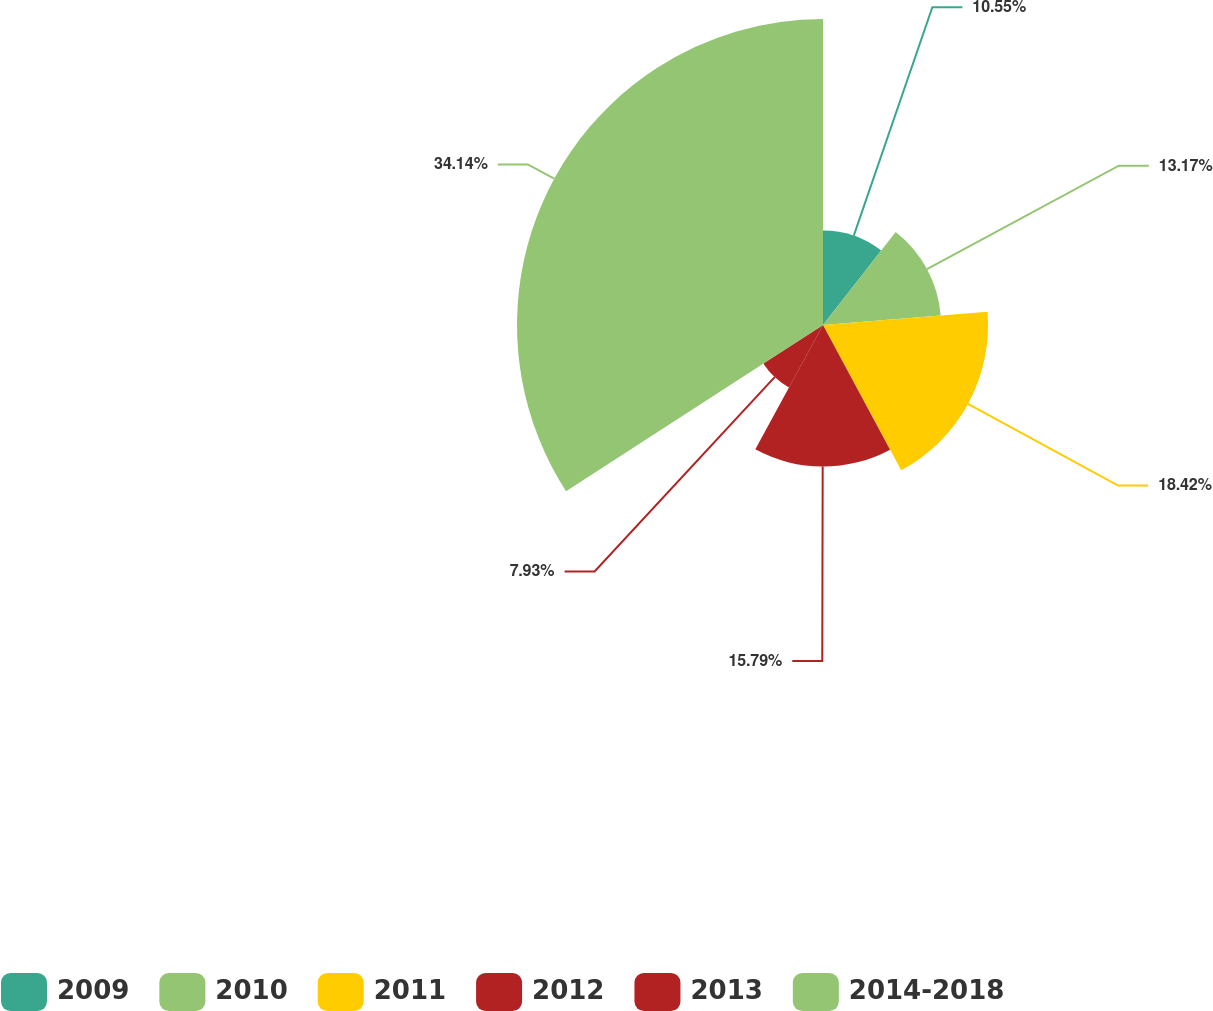<chart> <loc_0><loc_0><loc_500><loc_500><pie_chart><fcel>2009<fcel>2010<fcel>2011<fcel>2012<fcel>2013<fcel>2014-2018<nl><fcel>10.55%<fcel>13.17%<fcel>18.41%<fcel>15.79%<fcel>7.93%<fcel>34.13%<nl></chart> 